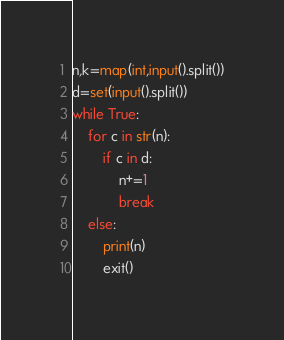<code> <loc_0><loc_0><loc_500><loc_500><_Python_>n,k=map(int,input().split())
d=set(input().split())
while True:
    for c in str(n):
        if c in d:
            n+=1
            break
    else:
        print(n)
        exit()</code> 